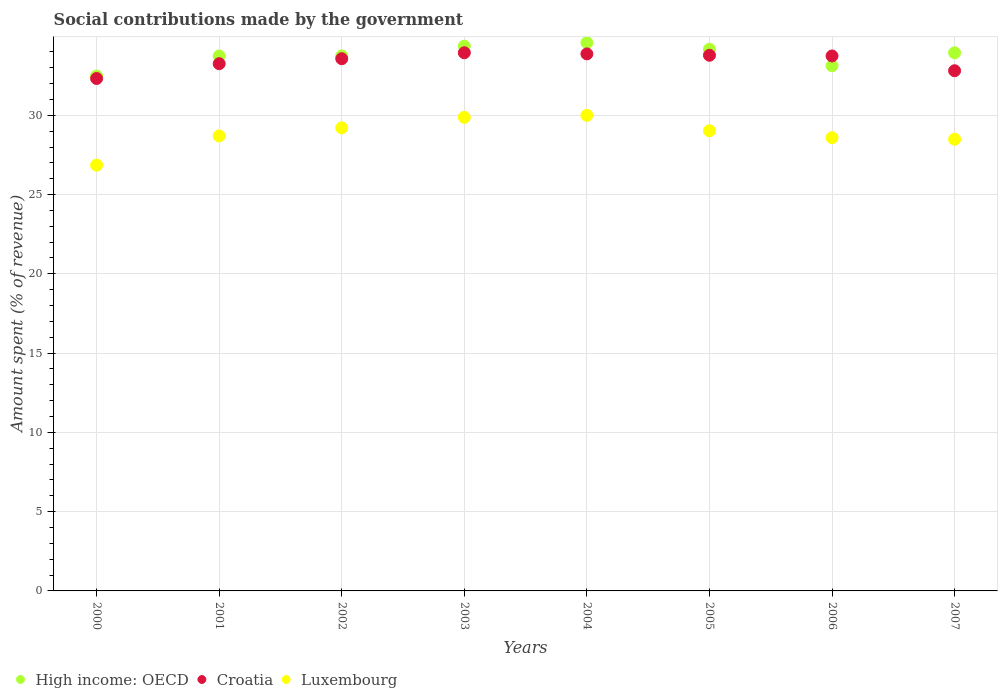What is the amount spent (in %) on social contributions in Croatia in 2001?
Provide a short and direct response. 33.26. Across all years, what is the maximum amount spent (in %) on social contributions in Luxembourg?
Offer a terse response. 30. Across all years, what is the minimum amount spent (in %) on social contributions in High income: OECD?
Ensure brevity in your answer.  32.48. In which year was the amount spent (in %) on social contributions in Croatia maximum?
Your response must be concise. 2003. In which year was the amount spent (in %) on social contributions in Luxembourg minimum?
Offer a very short reply. 2000. What is the total amount spent (in %) on social contributions in Croatia in the graph?
Your answer should be compact. 267.32. What is the difference between the amount spent (in %) on social contributions in High income: OECD in 2004 and that in 2005?
Keep it short and to the point. 0.41. What is the difference between the amount spent (in %) on social contributions in Luxembourg in 2003 and the amount spent (in %) on social contributions in High income: OECD in 2001?
Your response must be concise. -3.87. What is the average amount spent (in %) on social contributions in High income: OECD per year?
Your response must be concise. 33.77. In the year 2003, what is the difference between the amount spent (in %) on social contributions in High income: OECD and amount spent (in %) on social contributions in Croatia?
Give a very brief answer. 0.41. What is the ratio of the amount spent (in %) on social contributions in Luxembourg in 2004 to that in 2006?
Your answer should be compact. 1.05. Is the amount spent (in %) on social contributions in High income: OECD in 2000 less than that in 2003?
Make the answer very short. Yes. What is the difference between the highest and the second highest amount spent (in %) on social contributions in Luxembourg?
Give a very brief answer. 0.13. What is the difference between the highest and the lowest amount spent (in %) on social contributions in Luxembourg?
Provide a succinct answer. 3.14. Is the amount spent (in %) on social contributions in Luxembourg strictly greater than the amount spent (in %) on social contributions in High income: OECD over the years?
Your answer should be very brief. No. How many dotlines are there?
Give a very brief answer. 3. What is the difference between two consecutive major ticks on the Y-axis?
Give a very brief answer. 5. Does the graph contain grids?
Provide a succinct answer. Yes. Where does the legend appear in the graph?
Offer a very short reply. Bottom left. How many legend labels are there?
Your answer should be very brief. 3. How are the legend labels stacked?
Provide a succinct answer. Horizontal. What is the title of the graph?
Provide a short and direct response. Social contributions made by the government. Does "Kiribati" appear as one of the legend labels in the graph?
Provide a short and direct response. No. What is the label or title of the Y-axis?
Provide a short and direct response. Amount spent (% of revenue). What is the Amount spent (% of revenue) in High income: OECD in 2000?
Provide a succinct answer. 32.48. What is the Amount spent (% of revenue) in Croatia in 2000?
Your response must be concise. 32.32. What is the Amount spent (% of revenue) of Luxembourg in 2000?
Ensure brevity in your answer.  26.86. What is the Amount spent (% of revenue) of High income: OECD in 2001?
Your response must be concise. 33.74. What is the Amount spent (% of revenue) in Croatia in 2001?
Provide a short and direct response. 33.26. What is the Amount spent (% of revenue) in Luxembourg in 2001?
Keep it short and to the point. 28.7. What is the Amount spent (% of revenue) in High income: OECD in 2002?
Provide a succinct answer. 33.74. What is the Amount spent (% of revenue) of Croatia in 2002?
Your answer should be compact. 33.57. What is the Amount spent (% of revenue) of Luxembourg in 2002?
Give a very brief answer. 29.21. What is the Amount spent (% of revenue) of High income: OECD in 2003?
Give a very brief answer. 34.36. What is the Amount spent (% of revenue) of Croatia in 2003?
Offer a very short reply. 33.95. What is the Amount spent (% of revenue) of Luxembourg in 2003?
Provide a succinct answer. 29.87. What is the Amount spent (% of revenue) in High income: OECD in 2004?
Your response must be concise. 34.58. What is the Amount spent (% of revenue) in Croatia in 2004?
Offer a very short reply. 33.87. What is the Amount spent (% of revenue) in Luxembourg in 2004?
Give a very brief answer. 30. What is the Amount spent (% of revenue) in High income: OECD in 2005?
Give a very brief answer. 34.17. What is the Amount spent (% of revenue) in Croatia in 2005?
Make the answer very short. 33.79. What is the Amount spent (% of revenue) of Luxembourg in 2005?
Provide a short and direct response. 29.03. What is the Amount spent (% of revenue) in High income: OECD in 2006?
Your answer should be very brief. 33.13. What is the Amount spent (% of revenue) in Croatia in 2006?
Give a very brief answer. 33.74. What is the Amount spent (% of revenue) in Luxembourg in 2006?
Offer a terse response. 28.59. What is the Amount spent (% of revenue) in High income: OECD in 2007?
Offer a terse response. 33.94. What is the Amount spent (% of revenue) of Croatia in 2007?
Your answer should be compact. 32.81. What is the Amount spent (% of revenue) in Luxembourg in 2007?
Offer a very short reply. 28.49. Across all years, what is the maximum Amount spent (% of revenue) of High income: OECD?
Offer a terse response. 34.58. Across all years, what is the maximum Amount spent (% of revenue) of Croatia?
Offer a very short reply. 33.95. Across all years, what is the maximum Amount spent (% of revenue) in Luxembourg?
Provide a short and direct response. 30. Across all years, what is the minimum Amount spent (% of revenue) in High income: OECD?
Provide a short and direct response. 32.48. Across all years, what is the minimum Amount spent (% of revenue) in Croatia?
Provide a short and direct response. 32.32. Across all years, what is the minimum Amount spent (% of revenue) in Luxembourg?
Keep it short and to the point. 26.86. What is the total Amount spent (% of revenue) in High income: OECD in the graph?
Give a very brief answer. 270.14. What is the total Amount spent (% of revenue) of Croatia in the graph?
Your answer should be compact. 267.32. What is the total Amount spent (% of revenue) of Luxembourg in the graph?
Offer a very short reply. 230.74. What is the difference between the Amount spent (% of revenue) of High income: OECD in 2000 and that in 2001?
Give a very brief answer. -1.27. What is the difference between the Amount spent (% of revenue) of Croatia in 2000 and that in 2001?
Offer a terse response. -0.94. What is the difference between the Amount spent (% of revenue) in Luxembourg in 2000 and that in 2001?
Offer a very short reply. -1.84. What is the difference between the Amount spent (% of revenue) of High income: OECD in 2000 and that in 2002?
Give a very brief answer. -1.27. What is the difference between the Amount spent (% of revenue) in Croatia in 2000 and that in 2002?
Offer a terse response. -1.25. What is the difference between the Amount spent (% of revenue) in Luxembourg in 2000 and that in 2002?
Your answer should be very brief. -2.35. What is the difference between the Amount spent (% of revenue) of High income: OECD in 2000 and that in 2003?
Your answer should be very brief. -1.88. What is the difference between the Amount spent (% of revenue) in Croatia in 2000 and that in 2003?
Offer a very short reply. -1.63. What is the difference between the Amount spent (% of revenue) in Luxembourg in 2000 and that in 2003?
Your response must be concise. -3.02. What is the difference between the Amount spent (% of revenue) of High income: OECD in 2000 and that in 2004?
Give a very brief answer. -2.1. What is the difference between the Amount spent (% of revenue) of Croatia in 2000 and that in 2004?
Your response must be concise. -1.55. What is the difference between the Amount spent (% of revenue) of Luxembourg in 2000 and that in 2004?
Give a very brief answer. -3.14. What is the difference between the Amount spent (% of revenue) of High income: OECD in 2000 and that in 2005?
Provide a succinct answer. -1.69. What is the difference between the Amount spent (% of revenue) of Croatia in 2000 and that in 2005?
Your answer should be very brief. -1.47. What is the difference between the Amount spent (% of revenue) in Luxembourg in 2000 and that in 2005?
Give a very brief answer. -2.17. What is the difference between the Amount spent (% of revenue) of High income: OECD in 2000 and that in 2006?
Ensure brevity in your answer.  -0.65. What is the difference between the Amount spent (% of revenue) of Croatia in 2000 and that in 2006?
Your response must be concise. -1.42. What is the difference between the Amount spent (% of revenue) of Luxembourg in 2000 and that in 2006?
Your answer should be very brief. -1.73. What is the difference between the Amount spent (% of revenue) in High income: OECD in 2000 and that in 2007?
Your answer should be very brief. -1.47. What is the difference between the Amount spent (% of revenue) of Croatia in 2000 and that in 2007?
Your answer should be very brief. -0.49. What is the difference between the Amount spent (% of revenue) in Luxembourg in 2000 and that in 2007?
Your answer should be very brief. -1.64. What is the difference between the Amount spent (% of revenue) in High income: OECD in 2001 and that in 2002?
Make the answer very short. -0. What is the difference between the Amount spent (% of revenue) in Croatia in 2001 and that in 2002?
Your answer should be very brief. -0.31. What is the difference between the Amount spent (% of revenue) in Luxembourg in 2001 and that in 2002?
Offer a terse response. -0.51. What is the difference between the Amount spent (% of revenue) in High income: OECD in 2001 and that in 2003?
Give a very brief answer. -0.62. What is the difference between the Amount spent (% of revenue) of Croatia in 2001 and that in 2003?
Provide a succinct answer. -0.69. What is the difference between the Amount spent (% of revenue) of Luxembourg in 2001 and that in 2003?
Ensure brevity in your answer.  -1.17. What is the difference between the Amount spent (% of revenue) of High income: OECD in 2001 and that in 2004?
Keep it short and to the point. -0.84. What is the difference between the Amount spent (% of revenue) of Croatia in 2001 and that in 2004?
Keep it short and to the point. -0.62. What is the difference between the Amount spent (% of revenue) in Luxembourg in 2001 and that in 2004?
Ensure brevity in your answer.  -1.3. What is the difference between the Amount spent (% of revenue) in High income: OECD in 2001 and that in 2005?
Your answer should be very brief. -0.43. What is the difference between the Amount spent (% of revenue) of Croatia in 2001 and that in 2005?
Your answer should be compact. -0.53. What is the difference between the Amount spent (% of revenue) of Luxembourg in 2001 and that in 2005?
Offer a terse response. -0.33. What is the difference between the Amount spent (% of revenue) of High income: OECD in 2001 and that in 2006?
Your answer should be very brief. 0.62. What is the difference between the Amount spent (% of revenue) in Croatia in 2001 and that in 2006?
Give a very brief answer. -0.49. What is the difference between the Amount spent (% of revenue) in Luxembourg in 2001 and that in 2006?
Offer a very short reply. 0.11. What is the difference between the Amount spent (% of revenue) of High income: OECD in 2001 and that in 2007?
Your response must be concise. -0.2. What is the difference between the Amount spent (% of revenue) of Croatia in 2001 and that in 2007?
Provide a succinct answer. 0.45. What is the difference between the Amount spent (% of revenue) in Luxembourg in 2001 and that in 2007?
Your response must be concise. 0.21. What is the difference between the Amount spent (% of revenue) in High income: OECD in 2002 and that in 2003?
Your answer should be very brief. -0.62. What is the difference between the Amount spent (% of revenue) in Croatia in 2002 and that in 2003?
Give a very brief answer. -0.38. What is the difference between the Amount spent (% of revenue) of Luxembourg in 2002 and that in 2003?
Keep it short and to the point. -0.66. What is the difference between the Amount spent (% of revenue) of High income: OECD in 2002 and that in 2004?
Keep it short and to the point. -0.84. What is the difference between the Amount spent (% of revenue) of Croatia in 2002 and that in 2004?
Your response must be concise. -0.3. What is the difference between the Amount spent (% of revenue) in Luxembourg in 2002 and that in 2004?
Your answer should be compact. -0.79. What is the difference between the Amount spent (% of revenue) of High income: OECD in 2002 and that in 2005?
Keep it short and to the point. -0.42. What is the difference between the Amount spent (% of revenue) of Croatia in 2002 and that in 2005?
Offer a terse response. -0.22. What is the difference between the Amount spent (% of revenue) in Luxembourg in 2002 and that in 2005?
Keep it short and to the point. 0.18. What is the difference between the Amount spent (% of revenue) in High income: OECD in 2002 and that in 2006?
Provide a succinct answer. 0.62. What is the difference between the Amount spent (% of revenue) in Croatia in 2002 and that in 2006?
Provide a succinct answer. -0.17. What is the difference between the Amount spent (% of revenue) of Luxembourg in 2002 and that in 2006?
Your answer should be compact. 0.62. What is the difference between the Amount spent (% of revenue) in High income: OECD in 2002 and that in 2007?
Provide a short and direct response. -0.2. What is the difference between the Amount spent (% of revenue) of Croatia in 2002 and that in 2007?
Offer a very short reply. 0.76. What is the difference between the Amount spent (% of revenue) in Luxembourg in 2002 and that in 2007?
Provide a short and direct response. 0.72. What is the difference between the Amount spent (% of revenue) in High income: OECD in 2003 and that in 2004?
Make the answer very short. -0.22. What is the difference between the Amount spent (% of revenue) of Croatia in 2003 and that in 2004?
Your response must be concise. 0.07. What is the difference between the Amount spent (% of revenue) of Luxembourg in 2003 and that in 2004?
Keep it short and to the point. -0.13. What is the difference between the Amount spent (% of revenue) of High income: OECD in 2003 and that in 2005?
Offer a very short reply. 0.19. What is the difference between the Amount spent (% of revenue) of Croatia in 2003 and that in 2005?
Your answer should be compact. 0.16. What is the difference between the Amount spent (% of revenue) of Luxembourg in 2003 and that in 2005?
Give a very brief answer. 0.85. What is the difference between the Amount spent (% of revenue) of High income: OECD in 2003 and that in 2006?
Give a very brief answer. 1.23. What is the difference between the Amount spent (% of revenue) in Croatia in 2003 and that in 2006?
Keep it short and to the point. 0.2. What is the difference between the Amount spent (% of revenue) of Luxembourg in 2003 and that in 2006?
Your answer should be very brief. 1.29. What is the difference between the Amount spent (% of revenue) of High income: OECD in 2003 and that in 2007?
Make the answer very short. 0.42. What is the difference between the Amount spent (% of revenue) in Croatia in 2003 and that in 2007?
Offer a very short reply. 1.14. What is the difference between the Amount spent (% of revenue) in Luxembourg in 2003 and that in 2007?
Ensure brevity in your answer.  1.38. What is the difference between the Amount spent (% of revenue) of High income: OECD in 2004 and that in 2005?
Give a very brief answer. 0.41. What is the difference between the Amount spent (% of revenue) in Croatia in 2004 and that in 2005?
Provide a short and direct response. 0.09. What is the difference between the Amount spent (% of revenue) of High income: OECD in 2004 and that in 2006?
Give a very brief answer. 1.45. What is the difference between the Amount spent (% of revenue) in Croatia in 2004 and that in 2006?
Offer a very short reply. 0.13. What is the difference between the Amount spent (% of revenue) of Luxembourg in 2004 and that in 2006?
Provide a short and direct response. 1.41. What is the difference between the Amount spent (% of revenue) in High income: OECD in 2004 and that in 2007?
Give a very brief answer. 0.64. What is the difference between the Amount spent (% of revenue) in Croatia in 2004 and that in 2007?
Your answer should be compact. 1.06. What is the difference between the Amount spent (% of revenue) of Luxembourg in 2004 and that in 2007?
Keep it short and to the point. 1.5. What is the difference between the Amount spent (% of revenue) of High income: OECD in 2005 and that in 2006?
Ensure brevity in your answer.  1.04. What is the difference between the Amount spent (% of revenue) of Croatia in 2005 and that in 2006?
Your answer should be very brief. 0.04. What is the difference between the Amount spent (% of revenue) in Luxembourg in 2005 and that in 2006?
Your response must be concise. 0.44. What is the difference between the Amount spent (% of revenue) in High income: OECD in 2005 and that in 2007?
Provide a succinct answer. 0.22. What is the difference between the Amount spent (% of revenue) of Croatia in 2005 and that in 2007?
Your answer should be very brief. 0.98. What is the difference between the Amount spent (% of revenue) in Luxembourg in 2005 and that in 2007?
Your answer should be compact. 0.53. What is the difference between the Amount spent (% of revenue) in High income: OECD in 2006 and that in 2007?
Offer a terse response. -0.82. What is the difference between the Amount spent (% of revenue) in Croatia in 2006 and that in 2007?
Give a very brief answer. 0.93. What is the difference between the Amount spent (% of revenue) of Luxembourg in 2006 and that in 2007?
Make the answer very short. 0.09. What is the difference between the Amount spent (% of revenue) in High income: OECD in 2000 and the Amount spent (% of revenue) in Croatia in 2001?
Your answer should be very brief. -0.78. What is the difference between the Amount spent (% of revenue) in High income: OECD in 2000 and the Amount spent (% of revenue) in Luxembourg in 2001?
Offer a very short reply. 3.78. What is the difference between the Amount spent (% of revenue) in Croatia in 2000 and the Amount spent (% of revenue) in Luxembourg in 2001?
Your answer should be very brief. 3.62. What is the difference between the Amount spent (% of revenue) in High income: OECD in 2000 and the Amount spent (% of revenue) in Croatia in 2002?
Keep it short and to the point. -1.1. What is the difference between the Amount spent (% of revenue) in High income: OECD in 2000 and the Amount spent (% of revenue) in Luxembourg in 2002?
Your answer should be compact. 3.27. What is the difference between the Amount spent (% of revenue) of Croatia in 2000 and the Amount spent (% of revenue) of Luxembourg in 2002?
Make the answer very short. 3.11. What is the difference between the Amount spent (% of revenue) of High income: OECD in 2000 and the Amount spent (% of revenue) of Croatia in 2003?
Offer a very short reply. -1.47. What is the difference between the Amount spent (% of revenue) in High income: OECD in 2000 and the Amount spent (% of revenue) in Luxembourg in 2003?
Your answer should be very brief. 2.6. What is the difference between the Amount spent (% of revenue) in Croatia in 2000 and the Amount spent (% of revenue) in Luxembourg in 2003?
Your answer should be compact. 2.45. What is the difference between the Amount spent (% of revenue) of High income: OECD in 2000 and the Amount spent (% of revenue) of Croatia in 2004?
Ensure brevity in your answer.  -1.4. What is the difference between the Amount spent (% of revenue) of High income: OECD in 2000 and the Amount spent (% of revenue) of Luxembourg in 2004?
Provide a short and direct response. 2.48. What is the difference between the Amount spent (% of revenue) of Croatia in 2000 and the Amount spent (% of revenue) of Luxembourg in 2004?
Give a very brief answer. 2.32. What is the difference between the Amount spent (% of revenue) of High income: OECD in 2000 and the Amount spent (% of revenue) of Croatia in 2005?
Your response must be concise. -1.31. What is the difference between the Amount spent (% of revenue) of High income: OECD in 2000 and the Amount spent (% of revenue) of Luxembourg in 2005?
Your response must be concise. 3.45. What is the difference between the Amount spent (% of revenue) in Croatia in 2000 and the Amount spent (% of revenue) in Luxembourg in 2005?
Offer a terse response. 3.3. What is the difference between the Amount spent (% of revenue) in High income: OECD in 2000 and the Amount spent (% of revenue) in Croatia in 2006?
Your response must be concise. -1.27. What is the difference between the Amount spent (% of revenue) of High income: OECD in 2000 and the Amount spent (% of revenue) of Luxembourg in 2006?
Provide a succinct answer. 3.89. What is the difference between the Amount spent (% of revenue) of Croatia in 2000 and the Amount spent (% of revenue) of Luxembourg in 2006?
Offer a very short reply. 3.74. What is the difference between the Amount spent (% of revenue) in High income: OECD in 2000 and the Amount spent (% of revenue) in Croatia in 2007?
Provide a succinct answer. -0.34. What is the difference between the Amount spent (% of revenue) in High income: OECD in 2000 and the Amount spent (% of revenue) in Luxembourg in 2007?
Your answer should be compact. 3.98. What is the difference between the Amount spent (% of revenue) in Croatia in 2000 and the Amount spent (% of revenue) in Luxembourg in 2007?
Your answer should be compact. 3.83. What is the difference between the Amount spent (% of revenue) of High income: OECD in 2001 and the Amount spent (% of revenue) of Croatia in 2002?
Provide a succinct answer. 0.17. What is the difference between the Amount spent (% of revenue) of High income: OECD in 2001 and the Amount spent (% of revenue) of Luxembourg in 2002?
Make the answer very short. 4.53. What is the difference between the Amount spent (% of revenue) in Croatia in 2001 and the Amount spent (% of revenue) in Luxembourg in 2002?
Offer a very short reply. 4.05. What is the difference between the Amount spent (% of revenue) in High income: OECD in 2001 and the Amount spent (% of revenue) in Croatia in 2003?
Your answer should be compact. -0.21. What is the difference between the Amount spent (% of revenue) in High income: OECD in 2001 and the Amount spent (% of revenue) in Luxembourg in 2003?
Your response must be concise. 3.87. What is the difference between the Amount spent (% of revenue) of Croatia in 2001 and the Amount spent (% of revenue) of Luxembourg in 2003?
Ensure brevity in your answer.  3.38. What is the difference between the Amount spent (% of revenue) in High income: OECD in 2001 and the Amount spent (% of revenue) in Croatia in 2004?
Provide a short and direct response. -0.13. What is the difference between the Amount spent (% of revenue) in High income: OECD in 2001 and the Amount spent (% of revenue) in Luxembourg in 2004?
Offer a very short reply. 3.74. What is the difference between the Amount spent (% of revenue) in Croatia in 2001 and the Amount spent (% of revenue) in Luxembourg in 2004?
Keep it short and to the point. 3.26. What is the difference between the Amount spent (% of revenue) of High income: OECD in 2001 and the Amount spent (% of revenue) of Croatia in 2005?
Your response must be concise. -0.05. What is the difference between the Amount spent (% of revenue) of High income: OECD in 2001 and the Amount spent (% of revenue) of Luxembourg in 2005?
Provide a short and direct response. 4.72. What is the difference between the Amount spent (% of revenue) of Croatia in 2001 and the Amount spent (% of revenue) of Luxembourg in 2005?
Ensure brevity in your answer.  4.23. What is the difference between the Amount spent (% of revenue) of High income: OECD in 2001 and the Amount spent (% of revenue) of Croatia in 2006?
Your response must be concise. -0. What is the difference between the Amount spent (% of revenue) in High income: OECD in 2001 and the Amount spent (% of revenue) in Luxembourg in 2006?
Make the answer very short. 5.15. What is the difference between the Amount spent (% of revenue) of Croatia in 2001 and the Amount spent (% of revenue) of Luxembourg in 2006?
Provide a succinct answer. 4.67. What is the difference between the Amount spent (% of revenue) of High income: OECD in 2001 and the Amount spent (% of revenue) of Croatia in 2007?
Your answer should be compact. 0.93. What is the difference between the Amount spent (% of revenue) of High income: OECD in 2001 and the Amount spent (% of revenue) of Luxembourg in 2007?
Your response must be concise. 5.25. What is the difference between the Amount spent (% of revenue) of Croatia in 2001 and the Amount spent (% of revenue) of Luxembourg in 2007?
Give a very brief answer. 4.76. What is the difference between the Amount spent (% of revenue) of High income: OECD in 2002 and the Amount spent (% of revenue) of Croatia in 2003?
Make the answer very short. -0.2. What is the difference between the Amount spent (% of revenue) of High income: OECD in 2002 and the Amount spent (% of revenue) of Luxembourg in 2003?
Provide a succinct answer. 3.87. What is the difference between the Amount spent (% of revenue) of Croatia in 2002 and the Amount spent (% of revenue) of Luxembourg in 2003?
Keep it short and to the point. 3.7. What is the difference between the Amount spent (% of revenue) in High income: OECD in 2002 and the Amount spent (% of revenue) in Croatia in 2004?
Keep it short and to the point. -0.13. What is the difference between the Amount spent (% of revenue) of High income: OECD in 2002 and the Amount spent (% of revenue) of Luxembourg in 2004?
Keep it short and to the point. 3.75. What is the difference between the Amount spent (% of revenue) of Croatia in 2002 and the Amount spent (% of revenue) of Luxembourg in 2004?
Make the answer very short. 3.57. What is the difference between the Amount spent (% of revenue) of High income: OECD in 2002 and the Amount spent (% of revenue) of Croatia in 2005?
Provide a short and direct response. -0.04. What is the difference between the Amount spent (% of revenue) of High income: OECD in 2002 and the Amount spent (% of revenue) of Luxembourg in 2005?
Provide a succinct answer. 4.72. What is the difference between the Amount spent (% of revenue) of Croatia in 2002 and the Amount spent (% of revenue) of Luxembourg in 2005?
Keep it short and to the point. 4.55. What is the difference between the Amount spent (% of revenue) in High income: OECD in 2002 and the Amount spent (% of revenue) in Croatia in 2006?
Offer a very short reply. -0. What is the difference between the Amount spent (% of revenue) of High income: OECD in 2002 and the Amount spent (% of revenue) of Luxembourg in 2006?
Offer a terse response. 5.16. What is the difference between the Amount spent (% of revenue) of Croatia in 2002 and the Amount spent (% of revenue) of Luxembourg in 2006?
Offer a very short reply. 4.98. What is the difference between the Amount spent (% of revenue) of High income: OECD in 2002 and the Amount spent (% of revenue) of Croatia in 2007?
Your response must be concise. 0.93. What is the difference between the Amount spent (% of revenue) of High income: OECD in 2002 and the Amount spent (% of revenue) of Luxembourg in 2007?
Provide a short and direct response. 5.25. What is the difference between the Amount spent (% of revenue) of Croatia in 2002 and the Amount spent (% of revenue) of Luxembourg in 2007?
Make the answer very short. 5.08. What is the difference between the Amount spent (% of revenue) in High income: OECD in 2003 and the Amount spent (% of revenue) in Croatia in 2004?
Keep it short and to the point. 0.48. What is the difference between the Amount spent (% of revenue) in High income: OECD in 2003 and the Amount spent (% of revenue) in Luxembourg in 2004?
Make the answer very short. 4.36. What is the difference between the Amount spent (% of revenue) in Croatia in 2003 and the Amount spent (% of revenue) in Luxembourg in 2004?
Keep it short and to the point. 3.95. What is the difference between the Amount spent (% of revenue) in High income: OECD in 2003 and the Amount spent (% of revenue) in Croatia in 2005?
Offer a terse response. 0.57. What is the difference between the Amount spent (% of revenue) of High income: OECD in 2003 and the Amount spent (% of revenue) of Luxembourg in 2005?
Give a very brief answer. 5.33. What is the difference between the Amount spent (% of revenue) of Croatia in 2003 and the Amount spent (% of revenue) of Luxembourg in 2005?
Give a very brief answer. 4.92. What is the difference between the Amount spent (% of revenue) in High income: OECD in 2003 and the Amount spent (% of revenue) in Croatia in 2006?
Make the answer very short. 0.61. What is the difference between the Amount spent (% of revenue) in High income: OECD in 2003 and the Amount spent (% of revenue) in Luxembourg in 2006?
Give a very brief answer. 5.77. What is the difference between the Amount spent (% of revenue) in Croatia in 2003 and the Amount spent (% of revenue) in Luxembourg in 2006?
Your answer should be very brief. 5.36. What is the difference between the Amount spent (% of revenue) in High income: OECD in 2003 and the Amount spent (% of revenue) in Croatia in 2007?
Your answer should be compact. 1.55. What is the difference between the Amount spent (% of revenue) in High income: OECD in 2003 and the Amount spent (% of revenue) in Luxembourg in 2007?
Your answer should be compact. 5.87. What is the difference between the Amount spent (% of revenue) of Croatia in 2003 and the Amount spent (% of revenue) of Luxembourg in 2007?
Provide a short and direct response. 5.45. What is the difference between the Amount spent (% of revenue) in High income: OECD in 2004 and the Amount spent (% of revenue) in Croatia in 2005?
Offer a terse response. 0.79. What is the difference between the Amount spent (% of revenue) in High income: OECD in 2004 and the Amount spent (% of revenue) in Luxembourg in 2005?
Your response must be concise. 5.56. What is the difference between the Amount spent (% of revenue) of Croatia in 2004 and the Amount spent (% of revenue) of Luxembourg in 2005?
Your answer should be very brief. 4.85. What is the difference between the Amount spent (% of revenue) of High income: OECD in 2004 and the Amount spent (% of revenue) of Croatia in 2006?
Provide a succinct answer. 0.84. What is the difference between the Amount spent (% of revenue) in High income: OECD in 2004 and the Amount spent (% of revenue) in Luxembourg in 2006?
Provide a short and direct response. 5.99. What is the difference between the Amount spent (% of revenue) of Croatia in 2004 and the Amount spent (% of revenue) of Luxembourg in 2006?
Your answer should be very brief. 5.29. What is the difference between the Amount spent (% of revenue) of High income: OECD in 2004 and the Amount spent (% of revenue) of Croatia in 2007?
Offer a terse response. 1.77. What is the difference between the Amount spent (% of revenue) in High income: OECD in 2004 and the Amount spent (% of revenue) in Luxembourg in 2007?
Provide a succinct answer. 6.09. What is the difference between the Amount spent (% of revenue) in Croatia in 2004 and the Amount spent (% of revenue) in Luxembourg in 2007?
Your response must be concise. 5.38. What is the difference between the Amount spent (% of revenue) in High income: OECD in 2005 and the Amount spent (% of revenue) in Croatia in 2006?
Provide a succinct answer. 0.42. What is the difference between the Amount spent (% of revenue) of High income: OECD in 2005 and the Amount spent (% of revenue) of Luxembourg in 2006?
Give a very brief answer. 5.58. What is the difference between the Amount spent (% of revenue) of Croatia in 2005 and the Amount spent (% of revenue) of Luxembourg in 2006?
Your answer should be very brief. 5.2. What is the difference between the Amount spent (% of revenue) of High income: OECD in 2005 and the Amount spent (% of revenue) of Croatia in 2007?
Ensure brevity in your answer.  1.36. What is the difference between the Amount spent (% of revenue) of High income: OECD in 2005 and the Amount spent (% of revenue) of Luxembourg in 2007?
Offer a very short reply. 5.67. What is the difference between the Amount spent (% of revenue) of Croatia in 2005 and the Amount spent (% of revenue) of Luxembourg in 2007?
Provide a succinct answer. 5.29. What is the difference between the Amount spent (% of revenue) of High income: OECD in 2006 and the Amount spent (% of revenue) of Croatia in 2007?
Ensure brevity in your answer.  0.31. What is the difference between the Amount spent (% of revenue) of High income: OECD in 2006 and the Amount spent (% of revenue) of Luxembourg in 2007?
Provide a short and direct response. 4.63. What is the difference between the Amount spent (% of revenue) of Croatia in 2006 and the Amount spent (% of revenue) of Luxembourg in 2007?
Provide a succinct answer. 5.25. What is the average Amount spent (% of revenue) of High income: OECD per year?
Ensure brevity in your answer.  33.77. What is the average Amount spent (% of revenue) in Croatia per year?
Ensure brevity in your answer.  33.41. What is the average Amount spent (% of revenue) of Luxembourg per year?
Offer a very short reply. 28.84. In the year 2000, what is the difference between the Amount spent (% of revenue) in High income: OECD and Amount spent (% of revenue) in Croatia?
Offer a terse response. 0.15. In the year 2000, what is the difference between the Amount spent (% of revenue) of High income: OECD and Amount spent (% of revenue) of Luxembourg?
Ensure brevity in your answer.  5.62. In the year 2000, what is the difference between the Amount spent (% of revenue) of Croatia and Amount spent (% of revenue) of Luxembourg?
Your answer should be very brief. 5.47. In the year 2001, what is the difference between the Amount spent (% of revenue) in High income: OECD and Amount spent (% of revenue) in Croatia?
Provide a short and direct response. 0.48. In the year 2001, what is the difference between the Amount spent (% of revenue) in High income: OECD and Amount spent (% of revenue) in Luxembourg?
Provide a succinct answer. 5.04. In the year 2001, what is the difference between the Amount spent (% of revenue) in Croatia and Amount spent (% of revenue) in Luxembourg?
Your response must be concise. 4.56. In the year 2002, what is the difference between the Amount spent (% of revenue) of High income: OECD and Amount spent (% of revenue) of Croatia?
Offer a very short reply. 0.17. In the year 2002, what is the difference between the Amount spent (% of revenue) in High income: OECD and Amount spent (% of revenue) in Luxembourg?
Your answer should be compact. 4.53. In the year 2002, what is the difference between the Amount spent (% of revenue) of Croatia and Amount spent (% of revenue) of Luxembourg?
Offer a terse response. 4.36. In the year 2003, what is the difference between the Amount spent (% of revenue) of High income: OECD and Amount spent (% of revenue) of Croatia?
Offer a very short reply. 0.41. In the year 2003, what is the difference between the Amount spent (% of revenue) in High income: OECD and Amount spent (% of revenue) in Luxembourg?
Provide a succinct answer. 4.49. In the year 2003, what is the difference between the Amount spent (% of revenue) in Croatia and Amount spent (% of revenue) in Luxembourg?
Keep it short and to the point. 4.08. In the year 2004, what is the difference between the Amount spent (% of revenue) of High income: OECD and Amount spent (% of revenue) of Croatia?
Keep it short and to the point. 0.71. In the year 2004, what is the difference between the Amount spent (% of revenue) of High income: OECD and Amount spent (% of revenue) of Luxembourg?
Provide a short and direct response. 4.58. In the year 2004, what is the difference between the Amount spent (% of revenue) in Croatia and Amount spent (% of revenue) in Luxembourg?
Offer a terse response. 3.88. In the year 2005, what is the difference between the Amount spent (% of revenue) of High income: OECD and Amount spent (% of revenue) of Croatia?
Offer a terse response. 0.38. In the year 2005, what is the difference between the Amount spent (% of revenue) in High income: OECD and Amount spent (% of revenue) in Luxembourg?
Your response must be concise. 5.14. In the year 2005, what is the difference between the Amount spent (% of revenue) of Croatia and Amount spent (% of revenue) of Luxembourg?
Offer a very short reply. 4.76. In the year 2006, what is the difference between the Amount spent (% of revenue) in High income: OECD and Amount spent (% of revenue) in Croatia?
Give a very brief answer. -0.62. In the year 2006, what is the difference between the Amount spent (% of revenue) of High income: OECD and Amount spent (% of revenue) of Luxembourg?
Provide a succinct answer. 4.54. In the year 2006, what is the difference between the Amount spent (% of revenue) in Croatia and Amount spent (% of revenue) in Luxembourg?
Provide a short and direct response. 5.16. In the year 2007, what is the difference between the Amount spent (% of revenue) in High income: OECD and Amount spent (% of revenue) in Croatia?
Offer a terse response. 1.13. In the year 2007, what is the difference between the Amount spent (% of revenue) of High income: OECD and Amount spent (% of revenue) of Luxembourg?
Make the answer very short. 5.45. In the year 2007, what is the difference between the Amount spent (% of revenue) of Croatia and Amount spent (% of revenue) of Luxembourg?
Provide a succinct answer. 4.32. What is the ratio of the Amount spent (% of revenue) of High income: OECD in 2000 to that in 2001?
Give a very brief answer. 0.96. What is the ratio of the Amount spent (% of revenue) of Croatia in 2000 to that in 2001?
Ensure brevity in your answer.  0.97. What is the ratio of the Amount spent (% of revenue) in Luxembourg in 2000 to that in 2001?
Give a very brief answer. 0.94. What is the ratio of the Amount spent (% of revenue) in High income: OECD in 2000 to that in 2002?
Offer a very short reply. 0.96. What is the ratio of the Amount spent (% of revenue) of Croatia in 2000 to that in 2002?
Your response must be concise. 0.96. What is the ratio of the Amount spent (% of revenue) in Luxembourg in 2000 to that in 2002?
Keep it short and to the point. 0.92. What is the ratio of the Amount spent (% of revenue) in High income: OECD in 2000 to that in 2003?
Your answer should be very brief. 0.95. What is the ratio of the Amount spent (% of revenue) in Croatia in 2000 to that in 2003?
Give a very brief answer. 0.95. What is the ratio of the Amount spent (% of revenue) in Luxembourg in 2000 to that in 2003?
Offer a very short reply. 0.9. What is the ratio of the Amount spent (% of revenue) in High income: OECD in 2000 to that in 2004?
Ensure brevity in your answer.  0.94. What is the ratio of the Amount spent (% of revenue) in Croatia in 2000 to that in 2004?
Ensure brevity in your answer.  0.95. What is the ratio of the Amount spent (% of revenue) in Luxembourg in 2000 to that in 2004?
Your answer should be compact. 0.9. What is the ratio of the Amount spent (% of revenue) in High income: OECD in 2000 to that in 2005?
Give a very brief answer. 0.95. What is the ratio of the Amount spent (% of revenue) in Croatia in 2000 to that in 2005?
Your answer should be compact. 0.96. What is the ratio of the Amount spent (% of revenue) in Luxembourg in 2000 to that in 2005?
Offer a very short reply. 0.93. What is the ratio of the Amount spent (% of revenue) in High income: OECD in 2000 to that in 2006?
Offer a terse response. 0.98. What is the ratio of the Amount spent (% of revenue) of Croatia in 2000 to that in 2006?
Keep it short and to the point. 0.96. What is the ratio of the Amount spent (% of revenue) of Luxembourg in 2000 to that in 2006?
Ensure brevity in your answer.  0.94. What is the ratio of the Amount spent (% of revenue) in High income: OECD in 2000 to that in 2007?
Your response must be concise. 0.96. What is the ratio of the Amount spent (% of revenue) of Croatia in 2000 to that in 2007?
Provide a short and direct response. 0.99. What is the ratio of the Amount spent (% of revenue) of Luxembourg in 2000 to that in 2007?
Your answer should be very brief. 0.94. What is the ratio of the Amount spent (% of revenue) in Croatia in 2001 to that in 2002?
Ensure brevity in your answer.  0.99. What is the ratio of the Amount spent (% of revenue) of Luxembourg in 2001 to that in 2002?
Your response must be concise. 0.98. What is the ratio of the Amount spent (% of revenue) in Croatia in 2001 to that in 2003?
Ensure brevity in your answer.  0.98. What is the ratio of the Amount spent (% of revenue) of Luxembourg in 2001 to that in 2003?
Your response must be concise. 0.96. What is the ratio of the Amount spent (% of revenue) of High income: OECD in 2001 to that in 2004?
Ensure brevity in your answer.  0.98. What is the ratio of the Amount spent (% of revenue) in Croatia in 2001 to that in 2004?
Your answer should be very brief. 0.98. What is the ratio of the Amount spent (% of revenue) of Luxembourg in 2001 to that in 2004?
Provide a short and direct response. 0.96. What is the ratio of the Amount spent (% of revenue) of High income: OECD in 2001 to that in 2005?
Offer a very short reply. 0.99. What is the ratio of the Amount spent (% of revenue) in Croatia in 2001 to that in 2005?
Offer a very short reply. 0.98. What is the ratio of the Amount spent (% of revenue) in High income: OECD in 2001 to that in 2006?
Keep it short and to the point. 1.02. What is the ratio of the Amount spent (% of revenue) of Croatia in 2001 to that in 2006?
Ensure brevity in your answer.  0.99. What is the ratio of the Amount spent (% of revenue) in Luxembourg in 2001 to that in 2006?
Make the answer very short. 1. What is the ratio of the Amount spent (% of revenue) of Croatia in 2001 to that in 2007?
Make the answer very short. 1.01. What is the ratio of the Amount spent (% of revenue) of Luxembourg in 2001 to that in 2007?
Your answer should be compact. 1.01. What is the ratio of the Amount spent (% of revenue) of High income: OECD in 2002 to that in 2003?
Provide a succinct answer. 0.98. What is the ratio of the Amount spent (% of revenue) of Croatia in 2002 to that in 2003?
Your answer should be compact. 0.99. What is the ratio of the Amount spent (% of revenue) in Luxembourg in 2002 to that in 2003?
Your response must be concise. 0.98. What is the ratio of the Amount spent (% of revenue) in High income: OECD in 2002 to that in 2004?
Your answer should be very brief. 0.98. What is the ratio of the Amount spent (% of revenue) in Croatia in 2002 to that in 2004?
Make the answer very short. 0.99. What is the ratio of the Amount spent (% of revenue) of Luxembourg in 2002 to that in 2004?
Your answer should be very brief. 0.97. What is the ratio of the Amount spent (% of revenue) in High income: OECD in 2002 to that in 2005?
Offer a terse response. 0.99. What is the ratio of the Amount spent (% of revenue) in Croatia in 2002 to that in 2005?
Offer a very short reply. 0.99. What is the ratio of the Amount spent (% of revenue) of Luxembourg in 2002 to that in 2005?
Provide a succinct answer. 1.01. What is the ratio of the Amount spent (% of revenue) of High income: OECD in 2002 to that in 2006?
Ensure brevity in your answer.  1.02. What is the ratio of the Amount spent (% of revenue) in Luxembourg in 2002 to that in 2006?
Provide a succinct answer. 1.02. What is the ratio of the Amount spent (% of revenue) in Croatia in 2002 to that in 2007?
Your answer should be compact. 1.02. What is the ratio of the Amount spent (% of revenue) of Luxembourg in 2002 to that in 2007?
Your response must be concise. 1.03. What is the ratio of the Amount spent (% of revenue) of Croatia in 2003 to that in 2004?
Provide a succinct answer. 1. What is the ratio of the Amount spent (% of revenue) of Luxembourg in 2003 to that in 2004?
Keep it short and to the point. 1. What is the ratio of the Amount spent (% of revenue) in High income: OECD in 2003 to that in 2005?
Your response must be concise. 1.01. What is the ratio of the Amount spent (% of revenue) of Croatia in 2003 to that in 2005?
Your answer should be very brief. 1. What is the ratio of the Amount spent (% of revenue) of Luxembourg in 2003 to that in 2005?
Ensure brevity in your answer.  1.03. What is the ratio of the Amount spent (% of revenue) in High income: OECD in 2003 to that in 2006?
Your answer should be compact. 1.04. What is the ratio of the Amount spent (% of revenue) of Luxembourg in 2003 to that in 2006?
Keep it short and to the point. 1.04. What is the ratio of the Amount spent (% of revenue) of High income: OECD in 2003 to that in 2007?
Make the answer very short. 1.01. What is the ratio of the Amount spent (% of revenue) in Croatia in 2003 to that in 2007?
Your answer should be very brief. 1.03. What is the ratio of the Amount spent (% of revenue) in Luxembourg in 2003 to that in 2007?
Your response must be concise. 1.05. What is the ratio of the Amount spent (% of revenue) of High income: OECD in 2004 to that in 2005?
Offer a very short reply. 1.01. What is the ratio of the Amount spent (% of revenue) in Luxembourg in 2004 to that in 2005?
Provide a short and direct response. 1.03. What is the ratio of the Amount spent (% of revenue) in High income: OECD in 2004 to that in 2006?
Ensure brevity in your answer.  1.04. What is the ratio of the Amount spent (% of revenue) of Croatia in 2004 to that in 2006?
Ensure brevity in your answer.  1. What is the ratio of the Amount spent (% of revenue) in Luxembourg in 2004 to that in 2006?
Keep it short and to the point. 1.05. What is the ratio of the Amount spent (% of revenue) of High income: OECD in 2004 to that in 2007?
Your answer should be very brief. 1.02. What is the ratio of the Amount spent (% of revenue) of Croatia in 2004 to that in 2007?
Your answer should be very brief. 1.03. What is the ratio of the Amount spent (% of revenue) in Luxembourg in 2004 to that in 2007?
Give a very brief answer. 1.05. What is the ratio of the Amount spent (% of revenue) of High income: OECD in 2005 to that in 2006?
Your response must be concise. 1.03. What is the ratio of the Amount spent (% of revenue) in Luxembourg in 2005 to that in 2006?
Your answer should be very brief. 1.02. What is the ratio of the Amount spent (% of revenue) of High income: OECD in 2005 to that in 2007?
Give a very brief answer. 1.01. What is the ratio of the Amount spent (% of revenue) of Croatia in 2005 to that in 2007?
Offer a terse response. 1.03. What is the ratio of the Amount spent (% of revenue) of Luxembourg in 2005 to that in 2007?
Keep it short and to the point. 1.02. What is the ratio of the Amount spent (% of revenue) in High income: OECD in 2006 to that in 2007?
Make the answer very short. 0.98. What is the ratio of the Amount spent (% of revenue) of Croatia in 2006 to that in 2007?
Your answer should be very brief. 1.03. What is the ratio of the Amount spent (% of revenue) of Luxembourg in 2006 to that in 2007?
Offer a very short reply. 1. What is the difference between the highest and the second highest Amount spent (% of revenue) in High income: OECD?
Your response must be concise. 0.22. What is the difference between the highest and the second highest Amount spent (% of revenue) of Croatia?
Provide a short and direct response. 0.07. What is the difference between the highest and the second highest Amount spent (% of revenue) in Luxembourg?
Provide a short and direct response. 0.13. What is the difference between the highest and the lowest Amount spent (% of revenue) in High income: OECD?
Offer a terse response. 2.1. What is the difference between the highest and the lowest Amount spent (% of revenue) of Croatia?
Make the answer very short. 1.63. What is the difference between the highest and the lowest Amount spent (% of revenue) of Luxembourg?
Give a very brief answer. 3.14. 